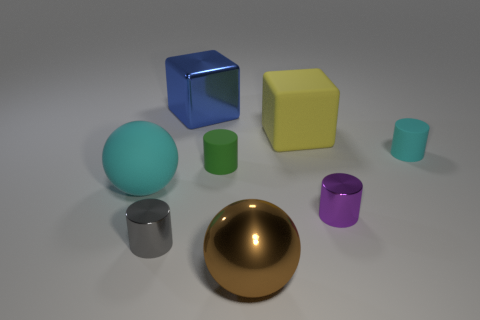What number of yellow objects are the same shape as the big blue shiny object? 1 